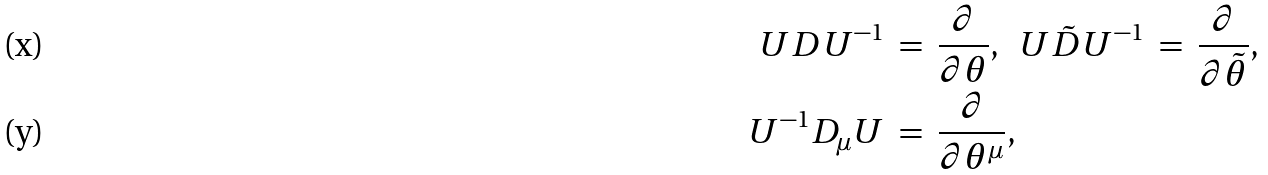<formula> <loc_0><loc_0><loc_500><loc_500>U D U ^ { - 1 } \ & = \ \frac { \partial } { \partial \theta } , \ \ U \tilde { D } U ^ { - 1 } \ = \ \frac { \partial } { \partial \tilde { \theta } } , \\ U ^ { - 1 } D _ { \mu } U \ & = \ \frac { \partial } { \partial \theta ^ { \mu } } ,</formula> 